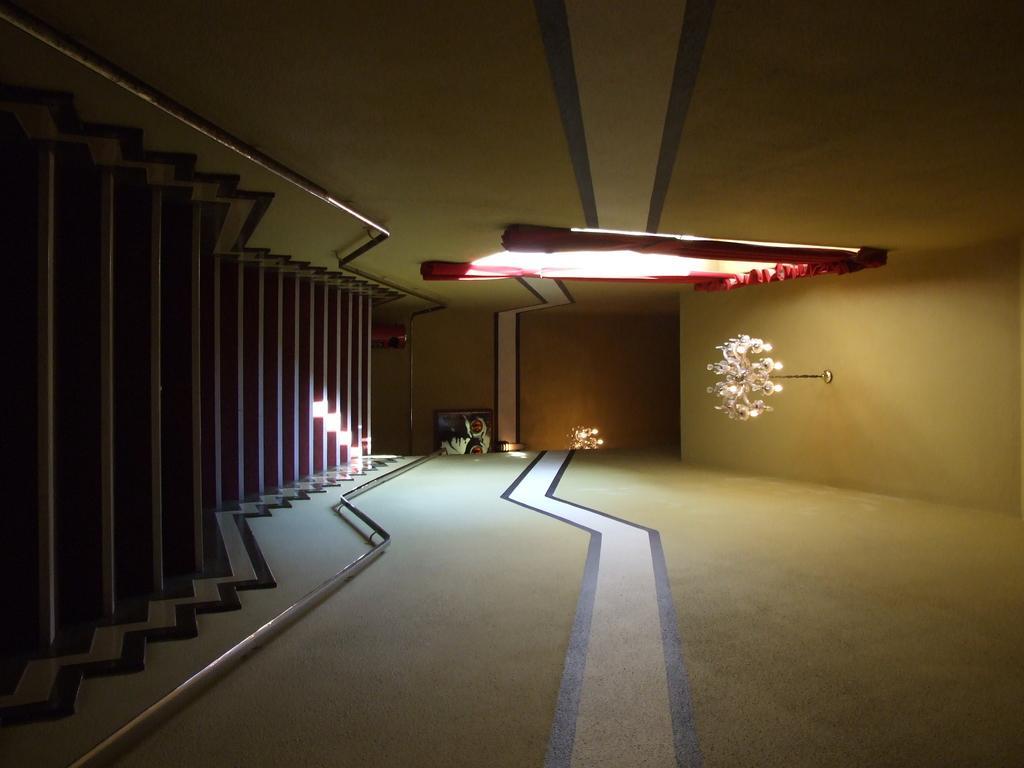In one or two sentences, can you explain what this image depicts? There are steps. On the left side, there is a window which is having a red color curtain. On the right side, there is a painting. Above these steps, there is a light which is attached to the roof. In the background, there is a light which is attached to the wall. 